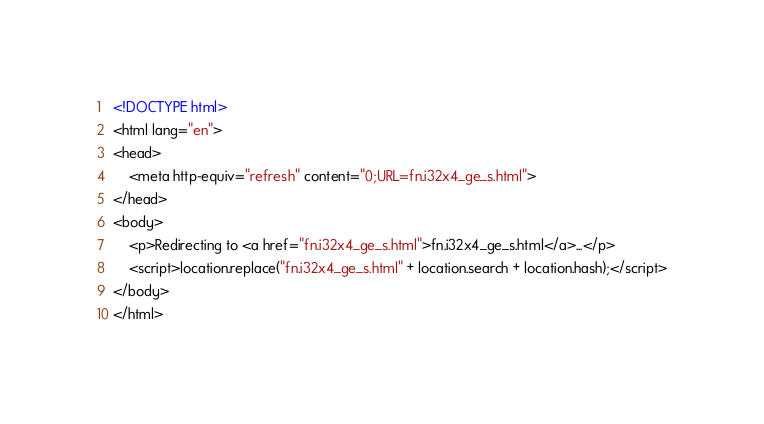<code> <loc_0><loc_0><loc_500><loc_500><_HTML_><!DOCTYPE html>
<html lang="en">
<head>
    <meta http-equiv="refresh" content="0;URL=fn.i32x4_ge_s.html">
</head>
<body>
    <p>Redirecting to <a href="fn.i32x4_ge_s.html">fn.i32x4_ge_s.html</a>...</p>
    <script>location.replace("fn.i32x4_ge_s.html" + location.search + location.hash);</script>
</body>
</html></code> 